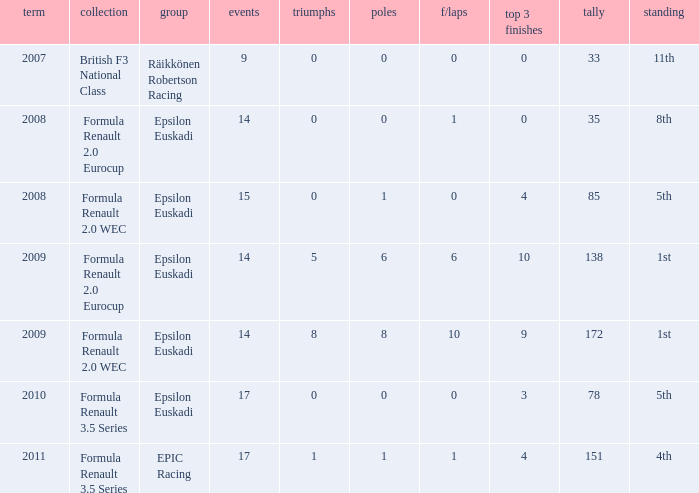How many podiums when he was in the british f3 national class series? 1.0. 